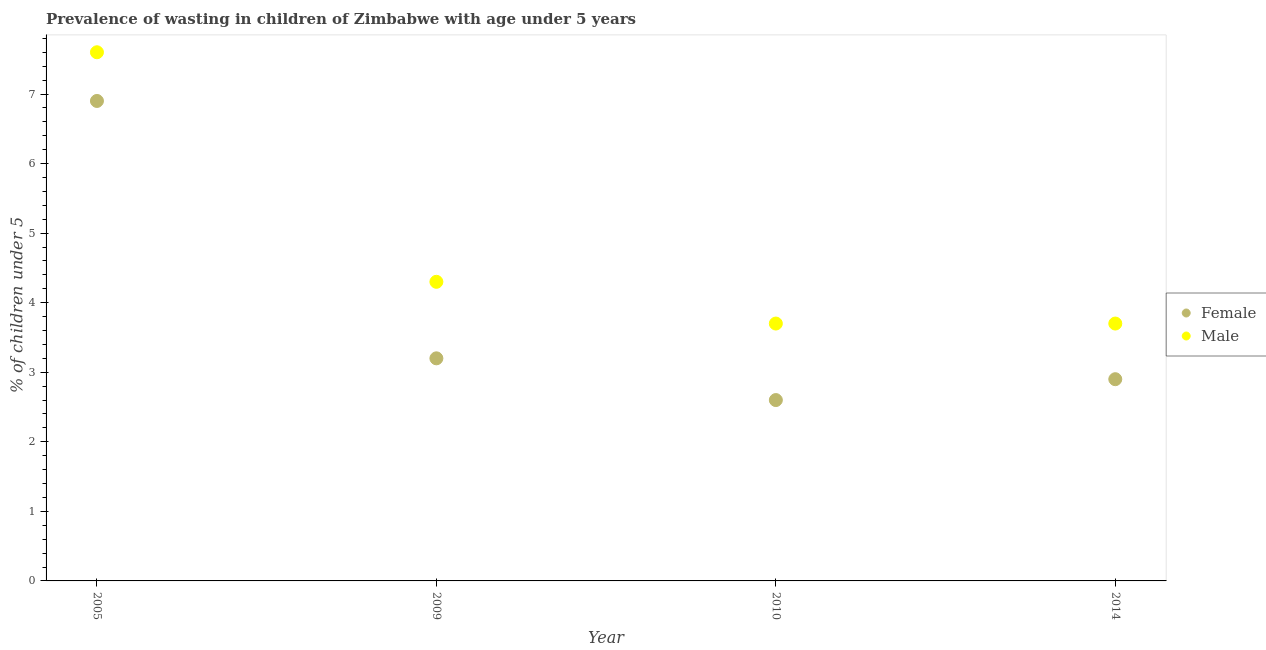What is the percentage of undernourished male children in 2009?
Your answer should be compact. 4.3. Across all years, what is the maximum percentage of undernourished male children?
Keep it short and to the point. 7.6. Across all years, what is the minimum percentage of undernourished male children?
Offer a terse response. 3.7. In which year was the percentage of undernourished female children maximum?
Your answer should be compact. 2005. In which year was the percentage of undernourished female children minimum?
Your response must be concise. 2010. What is the total percentage of undernourished male children in the graph?
Provide a short and direct response. 19.3. What is the difference between the percentage of undernourished male children in 2005 and that in 2010?
Your answer should be compact. 3.9. What is the difference between the percentage of undernourished male children in 2014 and the percentage of undernourished female children in 2009?
Provide a succinct answer. 0.5. What is the average percentage of undernourished female children per year?
Offer a very short reply. 3.9. In the year 2005, what is the difference between the percentage of undernourished female children and percentage of undernourished male children?
Your response must be concise. -0.7. In how many years, is the percentage of undernourished male children greater than 3.2 %?
Keep it short and to the point. 4. What is the ratio of the percentage of undernourished male children in 2009 to that in 2010?
Your response must be concise. 1.16. Is the percentage of undernourished male children in 2010 less than that in 2014?
Your answer should be compact. No. Is the difference between the percentage of undernourished male children in 2005 and 2010 greater than the difference between the percentage of undernourished female children in 2005 and 2010?
Ensure brevity in your answer.  No. What is the difference between the highest and the second highest percentage of undernourished female children?
Offer a terse response. 3.7. What is the difference between the highest and the lowest percentage of undernourished female children?
Keep it short and to the point. 4.3. In how many years, is the percentage of undernourished male children greater than the average percentage of undernourished male children taken over all years?
Provide a succinct answer. 1. Is the sum of the percentage of undernourished female children in 2009 and 2014 greater than the maximum percentage of undernourished male children across all years?
Your answer should be compact. No. Does the percentage of undernourished female children monotonically increase over the years?
Make the answer very short. No. Is the percentage of undernourished male children strictly less than the percentage of undernourished female children over the years?
Offer a very short reply. No. How many dotlines are there?
Ensure brevity in your answer.  2. How many years are there in the graph?
Offer a very short reply. 4. What is the difference between two consecutive major ticks on the Y-axis?
Your response must be concise. 1. Are the values on the major ticks of Y-axis written in scientific E-notation?
Keep it short and to the point. No. Does the graph contain grids?
Offer a very short reply. No. What is the title of the graph?
Provide a succinct answer. Prevalence of wasting in children of Zimbabwe with age under 5 years. Does "Male population" appear as one of the legend labels in the graph?
Your answer should be very brief. No. What is the label or title of the X-axis?
Make the answer very short. Year. What is the label or title of the Y-axis?
Ensure brevity in your answer.   % of children under 5. What is the  % of children under 5 of Female in 2005?
Your answer should be very brief. 6.9. What is the  % of children under 5 in Male in 2005?
Offer a terse response. 7.6. What is the  % of children under 5 in Female in 2009?
Your response must be concise. 3.2. What is the  % of children under 5 of Male in 2009?
Provide a short and direct response. 4.3. What is the  % of children under 5 of Female in 2010?
Provide a short and direct response. 2.6. What is the  % of children under 5 in Male in 2010?
Your answer should be compact. 3.7. What is the  % of children under 5 in Female in 2014?
Offer a very short reply. 2.9. What is the  % of children under 5 of Male in 2014?
Keep it short and to the point. 3.7. Across all years, what is the maximum  % of children under 5 of Female?
Give a very brief answer. 6.9. Across all years, what is the maximum  % of children under 5 of Male?
Keep it short and to the point. 7.6. Across all years, what is the minimum  % of children under 5 in Female?
Offer a very short reply. 2.6. Across all years, what is the minimum  % of children under 5 of Male?
Your answer should be very brief. 3.7. What is the total  % of children under 5 of Male in the graph?
Keep it short and to the point. 19.3. What is the difference between the  % of children under 5 of Female in 2005 and that in 2009?
Give a very brief answer. 3.7. What is the difference between the  % of children under 5 in Female in 2005 and that in 2010?
Provide a succinct answer. 4.3. What is the difference between the  % of children under 5 of Male in 2009 and that in 2010?
Give a very brief answer. 0.6. What is the difference between the  % of children under 5 in Male in 2010 and that in 2014?
Your answer should be very brief. 0. What is the difference between the  % of children under 5 of Female in 2005 and the  % of children under 5 of Male in 2009?
Keep it short and to the point. 2.6. What is the difference between the  % of children under 5 of Female in 2005 and the  % of children under 5 of Male in 2014?
Make the answer very short. 3.2. What is the difference between the  % of children under 5 of Female in 2010 and the  % of children under 5 of Male in 2014?
Your response must be concise. -1.1. What is the average  % of children under 5 in Male per year?
Keep it short and to the point. 4.83. In the year 2005, what is the difference between the  % of children under 5 in Female and  % of children under 5 in Male?
Provide a short and direct response. -0.7. In the year 2009, what is the difference between the  % of children under 5 of Female and  % of children under 5 of Male?
Ensure brevity in your answer.  -1.1. In the year 2010, what is the difference between the  % of children under 5 in Female and  % of children under 5 in Male?
Your answer should be compact. -1.1. In the year 2014, what is the difference between the  % of children under 5 in Female and  % of children under 5 in Male?
Keep it short and to the point. -0.8. What is the ratio of the  % of children under 5 of Female in 2005 to that in 2009?
Provide a succinct answer. 2.16. What is the ratio of the  % of children under 5 of Male in 2005 to that in 2009?
Keep it short and to the point. 1.77. What is the ratio of the  % of children under 5 of Female in 2005 to that in 2010?
Offer a terse response. 2.65. What is the ratio of the  % of children under 5 in Male in 2005 to that in 2010?
Make the answer very short. 2.05. What is the ratio of the  % of children under 5 in Female in 2005 to that in 2014?
Give a very brief answer. 2.38. What is the ratio of the  % of children under 5 in Male in 2005 to that in 2014?
Offer a very short reply. 2.05. What is the ratio of the  % of children under 5 of Female in 2009 to that in 2010?
Offer a terse response. 1.23. What is the ratio of the  % of children under 5 of Male in 2009 to that in 2010?
Keep it short and to the point. 1.16. What is the ratio of the  % of children under 5 of Female in 2009 to that in 2014?
Your response must be concise. 1.1. What is the ratio of the  % of children under 5 in Male in 2009 to that in 2014?
Offer a very short reply. 1.16. What is the ratio of the  % of children under 5 in Female in 2010 to that in 2014?
Keep it short and to the point. 0.9. What is the difference between the highest and the second highest  % of children under 5 in Female?
Offer a very short reply. 3.7. What is the difference between the highest and the second highest  % of children under 5 in Male?
Give a very brief answer. 3.3. 